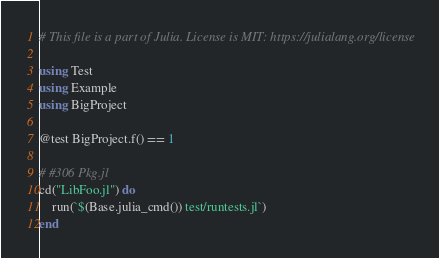<code> <loc_0><loc_0><loc_500><loc_500><_Julia_># This file is a part of Julia. License is MIT: https://julialang.org/license

using Test
using Example
using BigProject

@test BigProject.f() == 1

# #306 Pkg.jl
cd("LibFoo.jl") do
    run(`$(Base.julia_cmd()) test/runtests.jl`)
end
</code> 